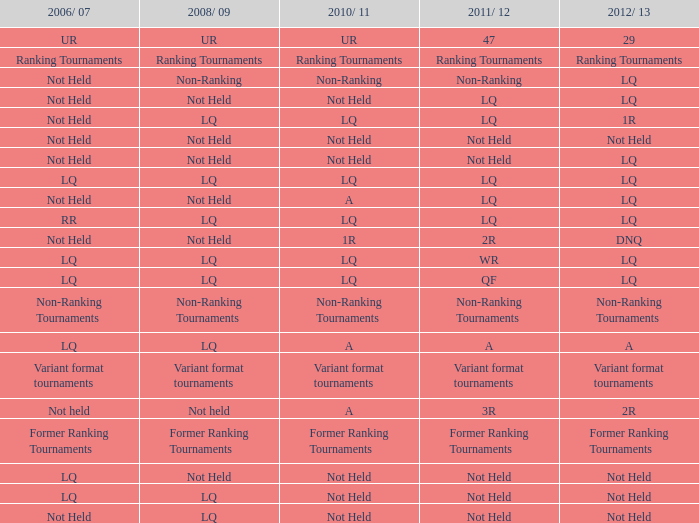What term is associated with 2006/07, given that 2008/09 is lq and 2010/11 is not held? LQ, Not Held. 